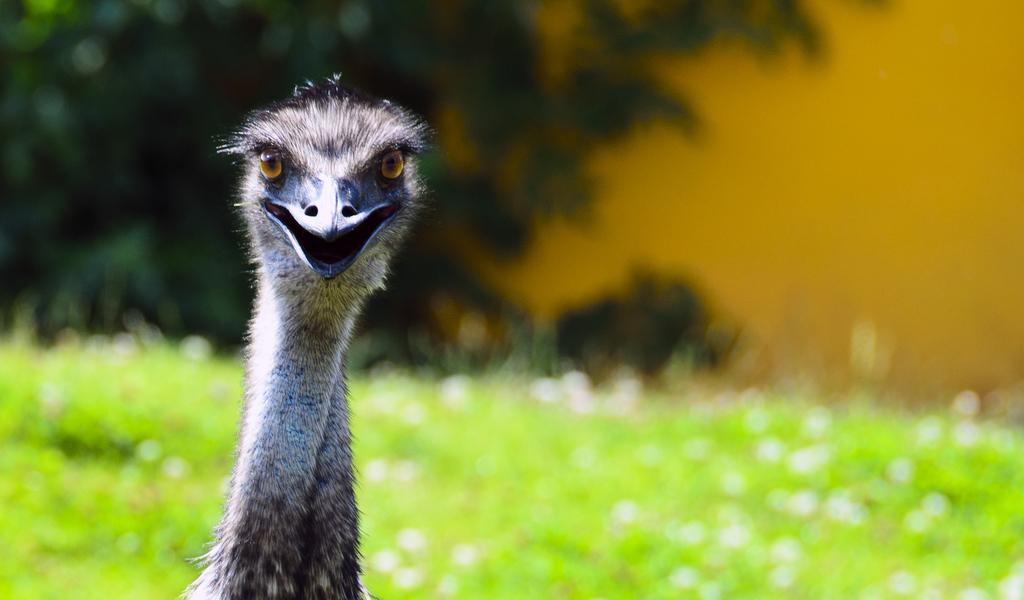What animal is the main subject of the picture? There is an ostrich in the picture. What can be seen in the background of the picture? There are trees and grass in the background of the picture. How would you describe the quality of the image? The image is blurry. What type of scissors can be seen cutting the grass in the image? There are no scissors present in the image; it features an ostrich and a background with trees and grass. 